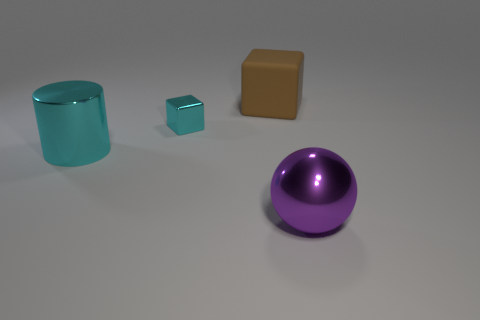Is there anything else that has the same size as the metallic block?
Your answer should be very brief. No. Are there any other things that have the same shape as the brown thing?
Provide a succinct answer. Yes. How many matte objects are cyan cubes or small cyan balls?
Your answer should be very brief. 0. Are there fewer purple metallic spheres that are behind the large cube than large cyan metallic objects?
Provide a short and direct response. Yes. There is a big shiny object that is behind the large purple metallic sphere to the right of the large metallic thing left of the brown object; what shape is it?
Your answer should be very brief. Cylinder. Is the big metallic sphere the same color as the tiny shiny thing?
Your response must be concise. No. Are there more blocks than big yellow cylinders?
Give a very brief answer. Yes. What number of other objects are the same material as the cyan cube?
Offer a terse response. 2. What number of things are either matte things or cyan objects right of the shiny cylinder?
Make the answer very short. 2. Is the number of large cyan shiny things less than the number of gray shiny cylinders?
Give a very brief answer. No. 